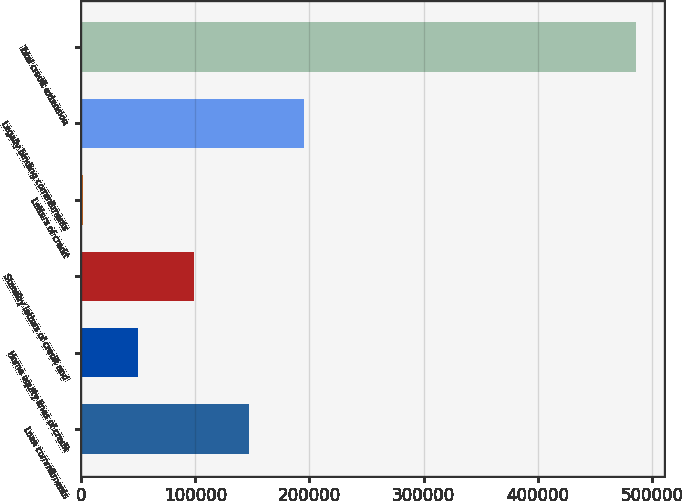Convert chart to OTSL. <chart><loc_0><loc_0><loc_500><loc_500><bar_chart><fcel>Loan commitments<fcel>Home equity lines of credit<fcel>Standby letters of credit and<fcel>Letters of credit<fcel>Legally binding commitments<fcel>Total credit extension<nl><fcel>147047<fcel>50115.8<fcel>98581.6<fcel>1650<fcel>195513<fcel>486308<nl></chart> 